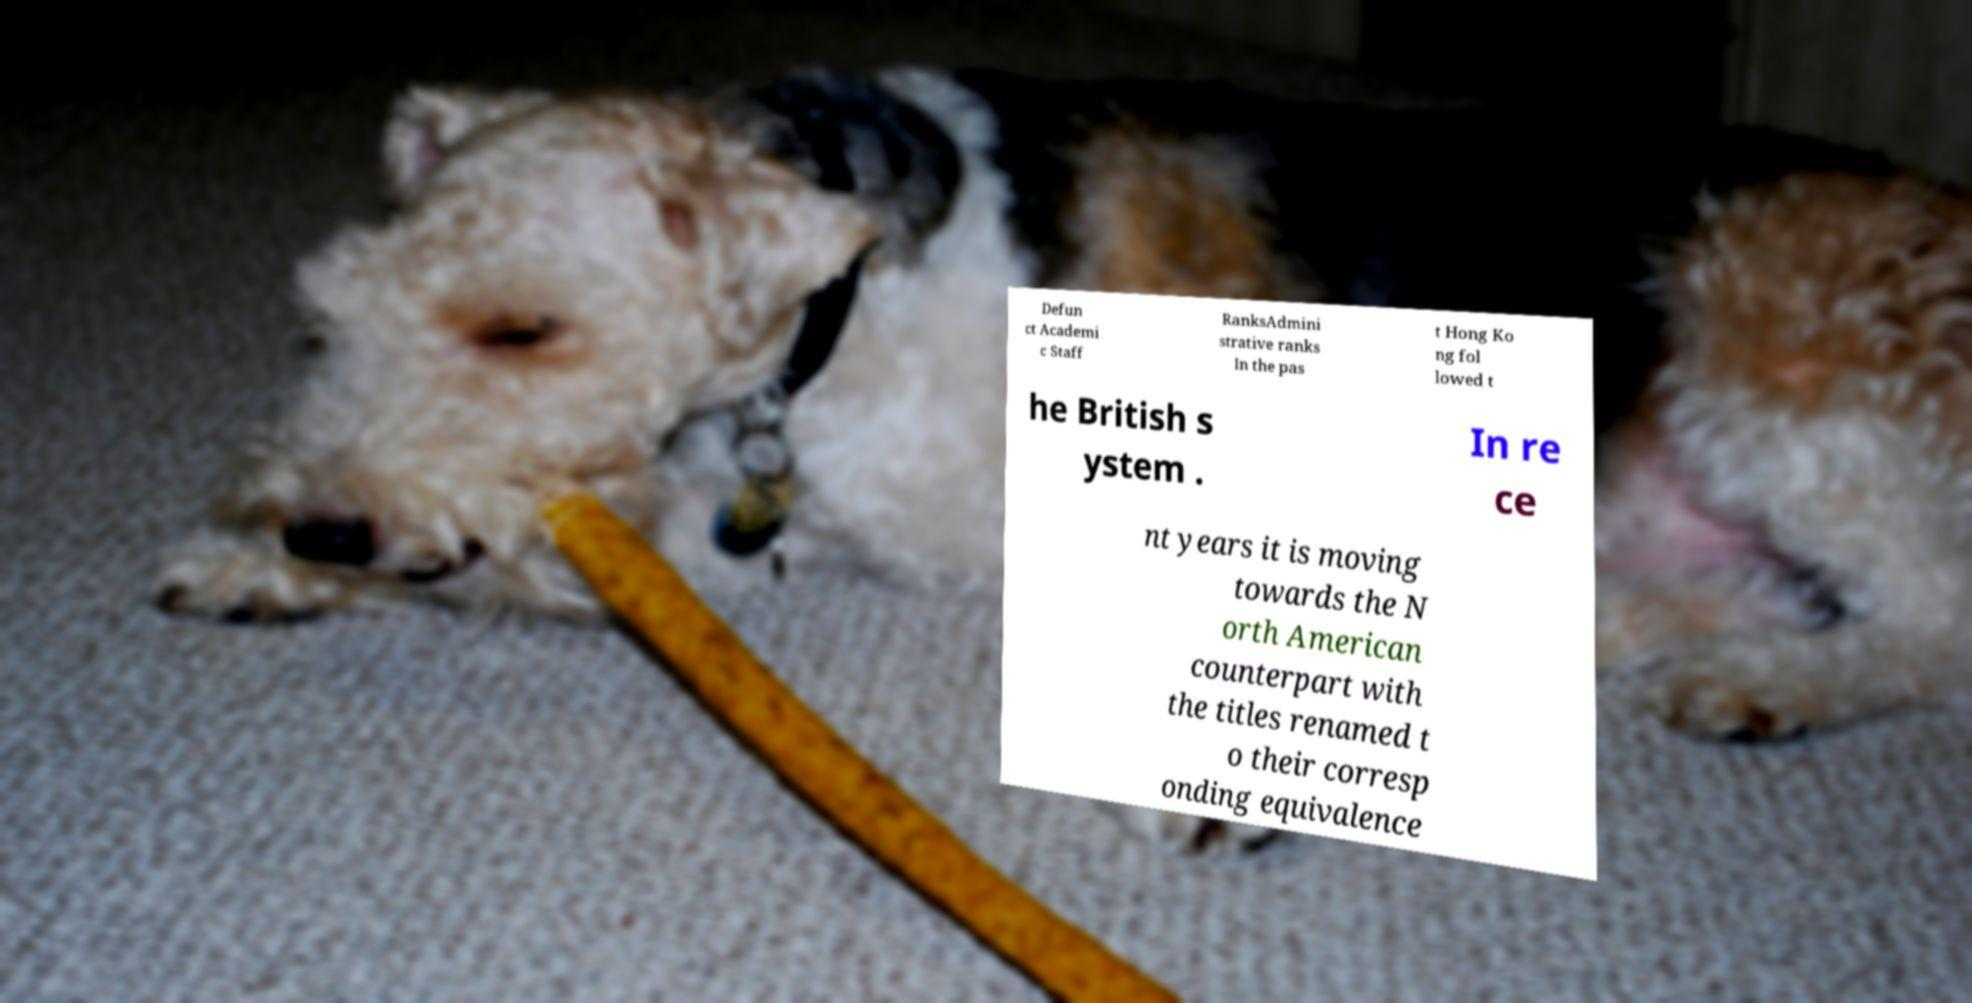Please read and relay the text visible in this image. What does it say? Defun ct Academi c Staff RanksAdmini strative ranks In the pas t Hong Ko ng fol lowed t he British s ystem . In re ce nt years it is moving towards the N orth American counterpart with the titles renamed t o their corresp onding equivalence 